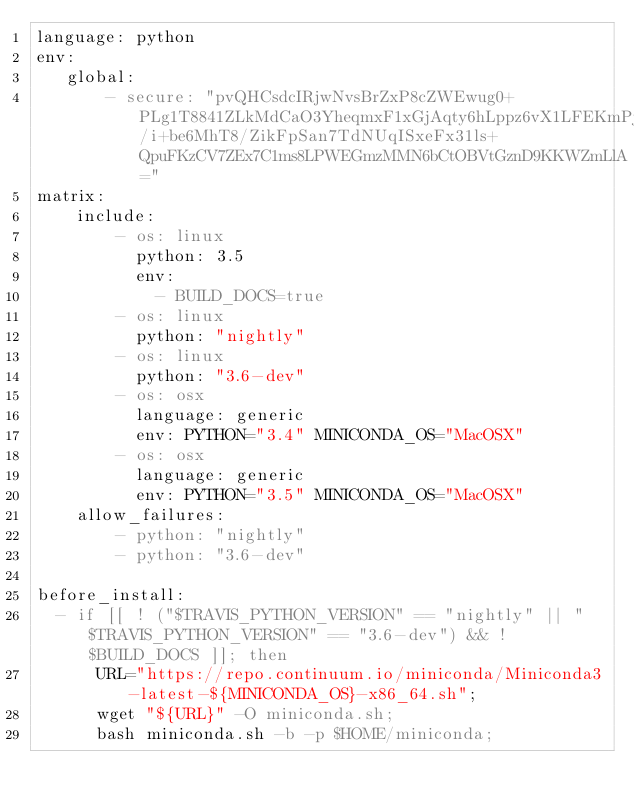Convert code to text. <code><loc_0><loc_0><loc_500><loc_500><_YAML_>language: python
env:
   global:
       - secure: "pvQHCsdcIRjwNvsBrZxP8cZWEwug0+PLg1T8841ZLkMdCaO3YheqmxF1xGjAqty6hLppz6vX1LFEKmPjKurLL0/i+be6MhT8/ZikFpSan7TdNUqISxeFx31ls+QpuFKzCV7ZEx7C1ms8LPWEGmzMMN6bCtOBVtGznD9KKWZmLlA="
matrix:
    include:
        - os: linux
          python: 3.5
          env:
            - BUILD_DOCS=true
        - os: linux
          python: "nightly"
        - os: linux
          python: "3.6-dev"
        - os: osx
          language: generic
          env: PYTHON="3.4" MINICONDA_OS="MacOSX"
        - os: osx
          language: generic
          env: PYTHON="3.5" MINICONDA_OS="MacOSX"
    allow_failures:
        - python: "nightly"
        - python: "3.6-dev"

before_install:
  - if [[ ! ("$TRAVIS_PYTHON_VERSION" == "nightly" || "$TRAVIS_PYTHON_VERSION" == "3.6-dev") && ! $BUILD_DOCS ]]; then
      URL="https://repo.continuum.io/miniconda/Miniconda3-latest-${MINICONDA_OS}-x86_64.sh";
      wget "${URL}" -O miniconda.sh;
      bash miniconda.sh -b -p $HOME/miniconda;</code> 